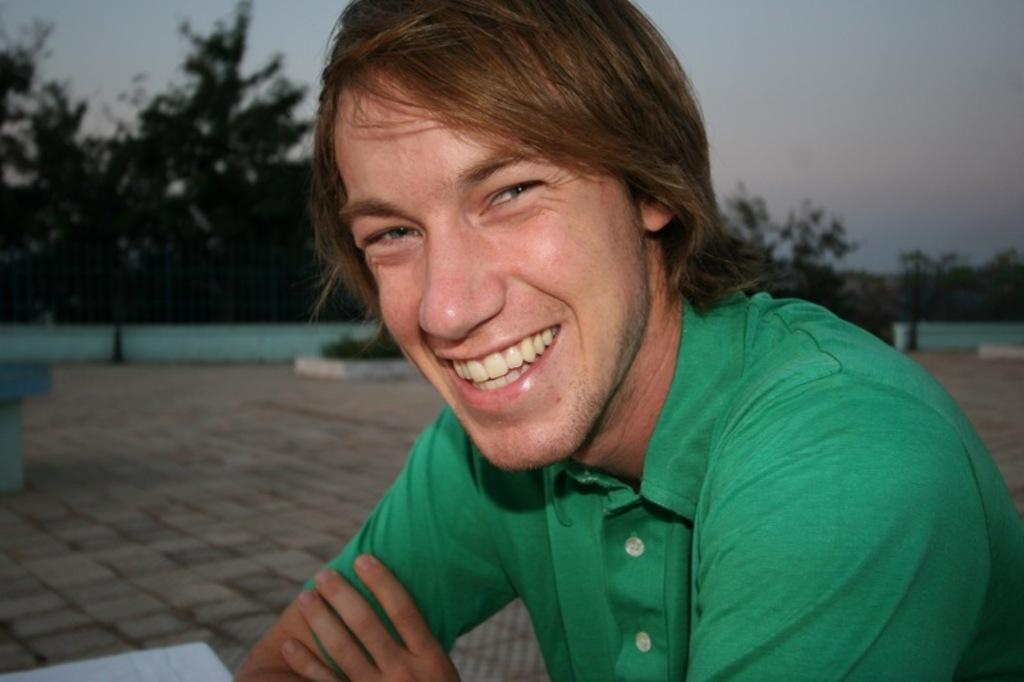What is the main subject of the image? The main subject of the image is a man. What is the man wearing in the image? The man is wearing a green t-shirt in the image. What is the man's facial expression in the image? The man is smiling in the image. What is the man doing in the image? The man is posing for the camera in the image. What can be seen in the background of the image? There is a blue color boundary wall and trees in the background of the image. Can you see any fangs in the image? No, there are no fangs present in the image. 